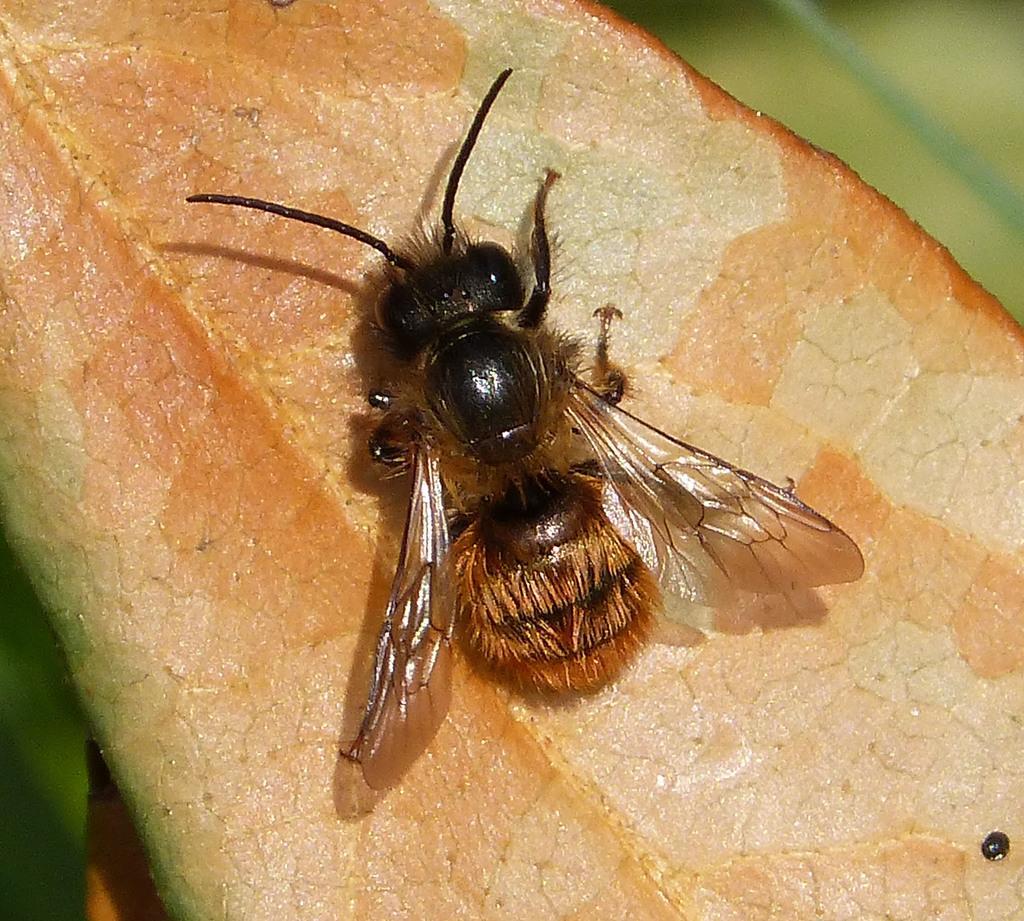Please provide a concise description of this image. This image consists of a fly on a leaf. It looks like the leaf is dried and it is in brown color. 